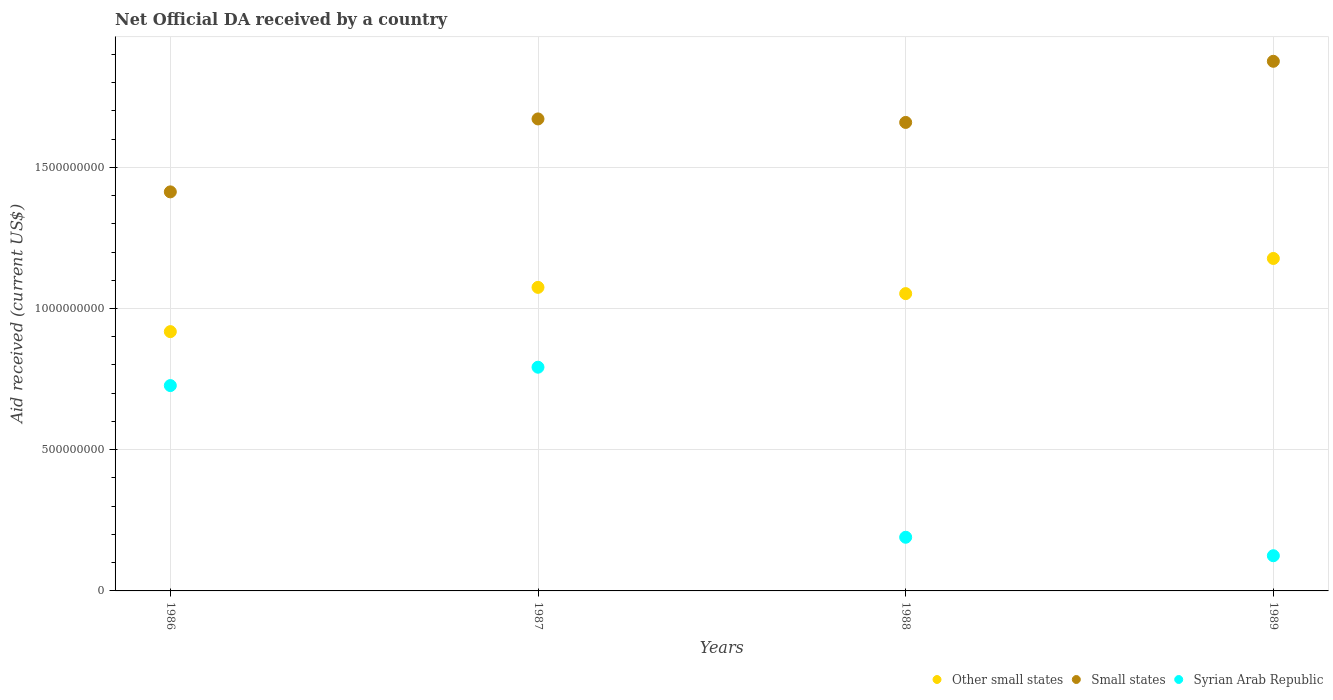Is the number of dotlines equal to the number of legend labels?
Offer a terse response. Yes. What is the net official development assistance aid received in Other small states in 1986?
Make the answer very short. 9.18e+08. Across all years, what is the maximum net official development assistance aid received in Other small states?
Provide a short and direct response. 1.18e+09. Across all years, what is the minimum net official development assistance aid received in Syrian Arab Republic?
Ensure brevity in your answer.  1.25e+08. In which year was the net official development assistance aid received in Other small states maximum?
Offer a very short reply. 1989. What is the total net official development assistance aid received in Syrian Arab Republic in the graph?
Your answer should be very brief. 1.83e+09. What is the difference between the net official development assistance aid received in Other small states in 1987 and that in 1989?
Your answer should be very brief. -1.02e+08. What is the difference between the net official development assistance aid received in Syrian Arab Republic in 1989 and the net official development assistance aid received in Small states in 1987?
Give a very brief answer. -1.55e+09. What is the average net official development assistance aid received in Other small states per year?
Offer a very short reply. 1.06e+09. In the year 1988, what is the difference between the net official development assistance aid received in Syrian Arab Republic and net official development assistance aid received in Other small states?
Your answer should be very brief. -8.63e+08. In how many years, is the net official development assistance aid received in Other small states greater than 100000000 US$?
Provide a short and direct response. 4. What is the ratio of the net official development assistance aid received in Syrian Arab Republic in 1986 to that in 1988?
Offer a terse response. 3.83. What is the difference between the highest and the second highest net official development assistance aid received in Other small states?
Make the answer very short. 1.02e+08. What is the difference between the highest and the lowest net official development assistance aid received in Syrian Arab Republic?
Your answer should be compact. 6.68e+08. Is it the case that in every year, the sum of the net official development assistance aid received in Small states and net official development assistance aid received in Syrian Arab Republic  is greater than the net official development assistance aid received in Other small states?
Your answer should be very brief. Yes. How many dotlines are there?
Your answer should be very brief. 3. Where does the legend appear in the graph?
Provide a succinct answer. Bottom right. What is the title of the graph?
Your answer should be compact. Net Official DA received by a country. What is the label or title of the X-axis?
Keep it short and to the point. Years. What is the label or title of the Y-axis?
Provide a succinct answer. Aid received (current US$). What is the Aid received (current US$) in Other small states in 1986?
Make the answer very short. 9.18e+08. What is the Aid received (current US$) in Small states in 1986?
Your response must be concise. 1.41e+09. What is the Aid received (current US$) of Syrian Arab Republic in 1986?
Your response must be concise. 7.27e+08. What is the Aid received (current US$) of Other small states in 1987?
Keep it short and to the point. 1.07e+09. What is the Aid received (current US$) in Small states in 1987?
Your answer should be compact. 1.67e+09. What is the Aid received (current US$) in Syrian Arab Republic in 1987?
Your response must be concise. 7.92e+08. What is the Aid received (current US$) of Other small states in 1988?
Offer a very short reply. 1.05e+09. What is the Aid received (current US$) in Small states in 1988?
Ensure brevity in your answer.  1.66e+09. What is the Aid received (current US$) in Syrian Arab Republic in 1988?
Your response must be concise. 1.90e+08. What is the Aid received (current US$) of Other small states in 1989?
Your answer should be compact. 1.18e+09. What is the Aid received (current US$) of Small states in 1989?
Ensure brevity in your answer.  1.88e+09. What is the Aid received (current US$) in Syrian Arab Republic in 1989?
Your answer should be very brief. 1.25e+08. Across all years, what is the maximum Aid received (current US$) in Other small states?
Provide a short and direct response. 1.18e+09. Across all years, what is the maximum Aid received (current US$) of Small states?
Ensure brevity in your answer.  1.88e+09. Across all years, what is the maximum Aid received (current US$) of Syrian Arab Republic?
Ensure brevity in your answer.  7.92e+08. Across all years, what is the minimum Aid received (current US$) of Other small states?
Your answer should be compact. 9.18e+08. Across all years, what is the minimum Aid received (current US$) in Small states?
Offer a very short reply. 1.41e+09. Across all years, what is the minimum Aid received (current US$) in Syrian Arab Republic?
Provide a short and direct response. 1.25e+08. What is the total Aid received (current US$) in Other small states in the graph?
Provide a succinct answer. 4.22e+09. What is the total Aid received (current US$) in Small states in the graph?
Your response must be concise. 6.62e+09. What is the total Aid received (current US$) of Syrian Arab Republic in the graph?
Give a very brief answer. 1.83e+09. What is the difference between the Aid received (current US$) of Other small states in 1986 and that in 1987?
Provide a short and direct response. -1.57e+08. What is the difference between the Aid received (current US$) in Small states in 1986 and that in 1987?
Keep it short and to the point. -2.58e+08. What is the difference between the Aid received (current US$) of Syrian Arab Republic in 1986 and that in 1987?
Offer a very short reply. -6.50e+07. What is the difference between the Aid received (current US$) in Other small states in 1986 and that in 1988?
Keep it short and to the point. -1.35e+08. What is the difference between the Aid received (current US$) in Small states in 1986 and that in 1988?
Offer a terse response. -2.46e+08. What is the difference between the Aid received (current US$) in Syrian Arab Republic in 1986 and that in 1988?
Provide a short and direct response. 5.37e+08. What is the difference between the Aid received (current US$) of Other small states in 1986 and that in 1989?
Offer a very short reply. -2.59e+08. What is the difference between the Aid received (current US$) in Small states in 1986 and that in 1989?
Offer a very short reply. -4.62e+08. What is the difference between the Aid received (current US$) in Syrian Arab Republic in 1986 and that in 1989?
Provide a succinct answer. 6.02e+08. What is the difference between the Aid received (current US$) of Other small states in 1987 and that in 1988?
Your response must be concise. 2.21e+07. What is the difference between the Aid received (current US$) of Small states in 1987 and that in 1988?
Offer a very short reply. 1.24e+07. What is the difference between the Aid received (current US$) in Syrian Arab Republic in 1987 and that in 1988?
Offer a very short reply. 6.02e+08. What is the difference between the Aid received (current US$) in Other small states in 1987 and that in 1989?
Ensure brevity in your answer.  -1.02e+08. What is the difference between the Aid received (current US$) in Small states in 1987 and that in 1989?
Your answer should be compact. -2.04e+08. What is the difference between the Aid received (current US$) in Syrian Arab Republic in 1987 and that in 1989?
Your answer should be compact. 6.68e+08. What is the difference between the Aid received (current US$) of Other small states in 1988 and that in 1989?
Your answer should be very brief. -1.24e+08. What is the difference between the Aid received (current US$) in Small states in 1988 and that in 1989?
Make the answer very short. -2.16e+08. What is the difference between the Aid received (current US$) of Syrian Arab Republic in 1988 and that in 1989?
Make the answer very short. 6.54e+07. What is the difference between the Aid received (current US$) of Other small states in 1986 and the Aid received (current US$) of Small states in 1987?
Provide a short and direct response. -7.53e+08. What is the difference between the Aid received (current US$) in Other small states in 1986 and the Aid received (current US$) in Syrian Arab Republic in 1987?
Your answer should be compact. 1.26e+08. What is the difference between the Aid received (current US$) in Small states in 1986 and the Aid received (current US$) in Syrian Arab Republic in 1987?
Give a very brief answer. 6.21e+08. What is the difference between the Aid received (current US$) of Other small states in 1986 and the Aid received (current US$) of Small states in 1988?
Offer a very short reply. -7.41e+08. What is the difference between the Aid received (current US$) in Other small states in 1986 and the Aid received (current US$) in Syrian Arab Republic in 1988?
Offer a very short reply. 7.28e+08. What is the difference between the Aid received (current US$) in Small states in 1986 and the Aid received (current US$) in Syrian Arab Republic in 1988?
Your response must be concise. 1.22e+09. What is the difference between the Aid received (current US$) in Other small states in 1986 and the Aid received (current US$) in Small states in 1989?
Make the answer very short. -9.57e+08. What is the difference between the Aid received (current US$) of Other small states in 1986 and the Aid received (current US$) of Syrian Arab Republic in 1989?
Provide a succinct answer. 7.93e+08. What is the difference between the Aid received (current US$) of Small states in 1986 and the Aid received (current US$) of Syrian Arab Republic in 1989?
Offer a terse response. 1.29e+09. What is the difference between the Aid received (current US$) of Other small states in 1987 and the Aid received (current US$) of Small states in 1988?
Your answer should be compact. -5.84e+08. What is the difference between the Aid received (current US$) of Other small states in 1987 and the Aid received (current US$) of Syrian Arab Republic in 1988?
Make the answer very short. 8.85e+08. What is the difference between the Aid received (current US$) in Small states in 1987 and the Aid received (current US$) in Syrian Arab Republic in 1988?
Give a very brief answer. 1.48e+09. What is the difference between the Aid received (current US$) in Other small states in 1987 and the Aid received (current US$) in Small states in 1989?
Your answer should be compact. -8.00e+08. What is the difference between the Aid received (current US$) of Other small states in 1987 and the Aid received (current US$) of Syrian Arab Republic in 1989?
Give a very brief answer. 9.50e+08. What is the difference between the Aid received (current US$) in Small states in 1987 and the Aid received (current US$) in Syrian Arab Republic in 1989?
Ensure brevity in your answer.  1.55e+09. What is the difference between the Aid received (current US$) in Other small states in 1988 and the Aid received (current US$) in Small states in 1989?
Provide a succinct answer. -8.23e+08. What is the difference between the Aid received (current US$) in Other small states in 1988 and the Aid received (current US$) in Syrian Arab Republic in 1989?
Provide a short and direct response. 9.28e+08. What is the difference between the Aid received (current US$) in Small states in 1988 and the Aid received (current US$) in Syrian Arab Republic in 1989?
Provide a short and direct response. 1.53e+09. What is the average Aid received (current US$) of Other small states per year?
Your response must be concise. 1.06e+09. What is the average Aid received (current US$) in Small states per year?
Give a very brief answer. 1.65e+09. What is the average Aid received (current US$) in Syrian Arab Republic per year?
Your answer should be compact. 4.58e+08. In the year 1986, what is the difference between the Aid received (current US$) of Other small states and Aid received (current US$) of Small states?
Give a very brief answer. -4.95e+08. In the year 1986, what is the difference between the Aid received (current US$) in Other small states and Aid received (current US$) in Syrian Arab Republic?
Provide a succinct answer. 1.91e+08. In the year 1986, what is the difference between the Aid received (current US$) in Small states and Aid received (current US$) in Syrian Arab Republic?
Provide a short and direct response. 6.86e+08. In the year 1987, what is the difference between the Aid received (current US$) in Other small states and Aid received (current US$) in Small states?
Offer a very short reply. -5.96e+08. In the year 1987, what is the difference between the Aid received (current US$) in Other small states and Aid received (current US$) in Syrian Arab Republic?
Ensure brevity in your answer.  2.83e+08. In the year 1987, what is the difference between the Aid received (current US$) in Small states and Aid received (current US$) in Syrian Arab Republic?
Make the answer very short. 8.79e+08. In the year 1988, what is the difference between the Aid received (current US$) of Other small states and Aid received (current US$) of Small states?
Your response must be concise. -6.06e+08. In the year 1988, what is the difference between the Aid received (current US$) of Other small states and Aid received (current US$) of Syrian Arab Republic?
Keep it short and to the point. 8.63e+08. In the year 1988, what is the difference between the Aid received (current US$) in Small states and Aid received (current US$) in Syrian Arab Republic?
Give a very brief answer. 1.47e+09. In the year 1989, what is the difference between the Aid received (current US$) in Other small states and Aid received (current US$) in Small states?
Keep it short and to the point. -6.98e+08. In the year 1989, what is the difference between the Aid received (current US$) of Other small states and Aid received (current US$) of Syrian Arab Republic?
Make the answer very short. 1.05e+09. In the year 1989, what is the difference between the Aid received (current US$) of Small states and Aid received (current US$) of Syrian Arab Republic?
Provide a succinct answer. 1.75e+09. What is the ratio of the Aid received (current US$) of Other small states in 1986 to that in 1987?
Your response must be concise. 0.85. What is the ratio of the Aid received (current US$) of Small states in 1986 to that in 1987?
Offer a terse response. 0.85. What is the ratio of the Aid received (current US$) of Syrian Arab Republic in 1986 to that in 1987?
Offer a very short reply. 0.92. What is the ratio of the Aid received (current US$) in Other small states in 1986 to that in 1988?
Your answer should be very brief. 0.87. What is the ratio of the Aid received (current US$) in Small states in 1986 to that in 1988?
Offer a very short reply. 0.85. What is the ratio of the Aid received (current US$) in Syrian Arab Republic in 1986 to that in 1988?
Your answer should be compact. 3.83. What is the ratio of the Aid received (current US$) in Other small states in 1986 to that in 1989?
Your answer should be compact. 0.78. What is the ratio of the Aid received (current US$) in Small states in 1986 to that in 1989?
Offer a terse response. 0.75. What is the ratio of the Aid received (current US$) of Syrian Arab Republic in 1986 to that in 1989?
Keep it short and to the point. 5.83. What is the ratio of the Aid received (current US$) in Other small states in 1987 to that in 1988?
Provide a succinct answer. 1.02. What is the ratio of the Aid received (current US$) in Small states in 1987 to that in 1988?
Ensure brevity in your answer.  1.01. What is the ratio of the Aid received (current US$) in Syrian Arab Republic in 1987 to that in 1988?
Your answer should be very brief. 4.17. What is the ratio of the Aid received (current US$) of Small states in 1987 to that in 1989?
Provide a short and direct response. 0.89. What is the ratio of the Aid received (current US$) of Syrian Arab Republic in 1987 to that in 1989?
Your answer should be very brief. 6.36. What is the ratio of the Aid received (current US$) of Other small states in 1988 to that in 1989?
Ensure brevity in your answer.  0.89. What is the ratio of the Aid received (current US$) in Small states in 1988 to that in 1989?
Ensure brevity in your answer.  0.88. What is the ratio of the Aid received (current US$) of Syrian Arab Republic in 1988 to that in 1989?
Your answer should be compact. 1.52. What is the difference between the highest and the second highest Aid received (current US$) in Other small states?
Ensure brevity in your answer.  1.02e+08. What is the difference between the highest and the second highest Aid received (current US$) of Small states?
Keep it short and to the point. 2.04e+08. What is the difference between the highest and the second highest Aid received (current US$) in Syrian Arab Republic?
Ensure brevity in your answer.  6.50e+07. What is the difference between the highest and the lowest Aid received (current US$) of Other small states?
Make the answer very short. 2.59e+08. What is the difference between the highest and the lowest Aid received (current US$) of Small states?
Give a very brief answer. 4.62e+08. What is the difference between the highest and the lowest Aid received (current US$) in Syrian Arab Republic?
Offer a terse response. 6.68e+08. 